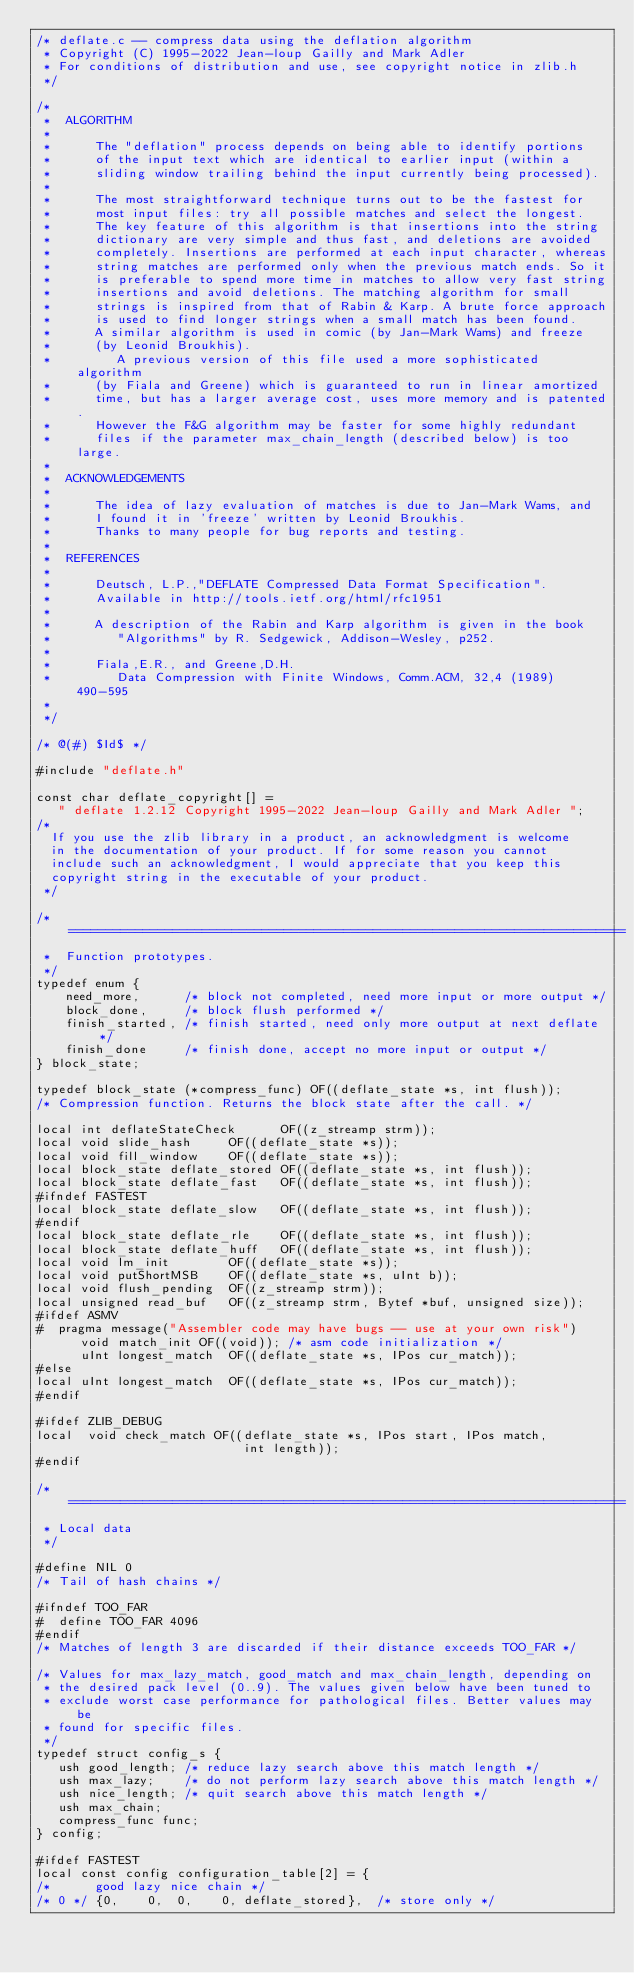<code> <loc_0><loc_0><loc_500><loc_500><_C_>/* deflate.c -- compress data using the deflation algorithm
 * Copyright (C) 1995-2022 Jean-loup Gailly and Mark Adler
 * For conditions of distribution and use, see copyright notice in zlib.h
 */

/*
 *  ALGORITHM
 *
 *      The "deflation" process depends on being able to identify portions
 *      of the input text which are identical to earlier input (within a
 *      sliding window trailing behind the input currently being processed).
 *
 *      The most straightforward technique turns out to be the fastest for
 *      most input files: try all possible matches and select the longest.
 *      The key feature of this algorithm is that insertions into the string
 *      dictionary are very simple and thus fast, and deletions are avoided
 *      completely. Insertions are performed at each input character, whereas
 *      string matches are performed only when the previous match ends. So it
 *      is preferable to spend more time in matches to allow very fast string
 *      insertions and avoid deletions. The matching algorithm for small
 *      strings is inspired from that of Rabin & Karp. A brute force approach
 *      is used to find longer strings when a small match has been found.
 *      A similar algorithm is used in comic (by Jan-Mark Wams) and freeze
 *      (by Leonid Broukhis).
 *         A previous version of this file used a more sophisticated algorithm
 *      (by Fiala and Greene) which is guaranteed to run in linear amortized
 *      time, but has a larger average cost, uses more memory and is patented.
 *      However the F&G algorithm may be faster for some highly redundant
 *      files if the parameter max_chain_length (described below) is too large.
 *
 *  ACKNOWLEDGEMENTS
 *
 *      The idea of lazy evaluation of matches is due to Jan-Mark Wams, and
 *      I found it in 'freeze' written by Leonid Broukhis.
 *      Thanks to many people for bug reports and testing.
 *
 *  REFERENCES
 *
 *      Deutsch, L.P.,"DEFLATE Compressed Data Format Specification".
 *      Available in http://tools.ietf.org/html/rfc1951
 *
 *      A description of the Rabin and Karp algorithm is given in the book
 *         "Algorithms" by R. Sedgewick, Addison-Wesley, p252.
 *
 *      Fiala,E.R., and Greene,D.H.
 *         Data Compression with Finite Windows, Comm.ACM, 32,4 (1989) 490-595
 *
 */

/* @(#) $Id$ */

#include "deflate.h"

const char deflate_copyright[] =
   " deflate 1.2.12 Copyright 1995-2022 Jean-loup Gailly and Mark Adler ";
/*
  If you use the zlib library in a product, an acknowledgment is welcome
  in the documentation of your product. If for some reason you cannot
  include such an acknowledgment, I would appreciate that you keep this
  copyright string in the executable of your product.
 */

/* ===========================================================================
 *  Function prototypes.
 */
typedef enum {
    need_more,      /* block not completed, need more input or more output */
    block_done,     /* block flush performed */
    finish_started, /* finish started, need only more output at next deflate */
    finish_done     /* finish done, accept no more input or output */
} block_state;

typedef block_state (*compress_func) OF((deflate_state *s, int flush));
/* Compression function. Returns the block state after the call. */

local int deflateStateCheck      OF((z_streamp strm));
local void slide_hash     OF((deflate_state *s));
local void fill_window    OF((deflate_state *s));
local block_state deflate_stored OF((deflate_state *s, int flush));
local block_state deflate_fast   OF((deflate_state *s, int flush));
#ifndef FASTEST
local block_state deflate_slow   OF((deflate_state *s, int flush));
#endif
local block_state deflate_rle    OF((deflate_state *s, int flush));
local block_state deflate_huff   OF((deflate_state *s, int flush));
local void lm_init        OF((deflate_state *s));
local void putShortMSB    OF((deflate_state *s, uInt b));
local void flush_pending  OF((z_streamp strm));
local unsigned read_buf   OF((z_streamp strm, Bytef *buf, unsigned size));
#ifdef ASMV
#  pragma message("Assembler code may have bugs -- use at your own risk")
      void match_init OF((void)); /* asm code initialization */
      uInt longest_match  OF((deflate_state *s, IPos cur_match));
#else
local uInt longest_match  OF((deflate_state *s, IPos cur_match));
#endif

#ifdef ZLIB_DEBUG
local  void check_match OF((deflate_state *s, IPos start, IPos match,
                            int length));
#endif

/* ===========================================================================
 * Local data
 */

#define NIL 0
/* Tail of hash chains */

#ifndef TOO_FAR
#  define TOO_FAR 4096
#endif
/* Matches of length 3 are discarded if their distance exceeds TOO_FAR */

/* Values for max_lazy_match, good_match and max_chain_length, depending on
 * the desired pack level (0..9). The values given below have been tuned to
 * exclude worst case performance for pathological files. Better values may be
 * found for specific files.
 */
typedef struct config_s {
   ush good_length; /* reduce lazy search above this match length */
   ush max_lazy;    /* do not perform lazy search above this match length */
   ush nice_length; /* quit search above this match length */
   ush max_chain;
   compress_func func;
} config;

#ifdef FASTEST
local const config configuration_table[2] = {
/*      good lazy nice chain */
/* 0 */ {0,    0,  0,    0, deflate_stored},  /* store only */</code> 